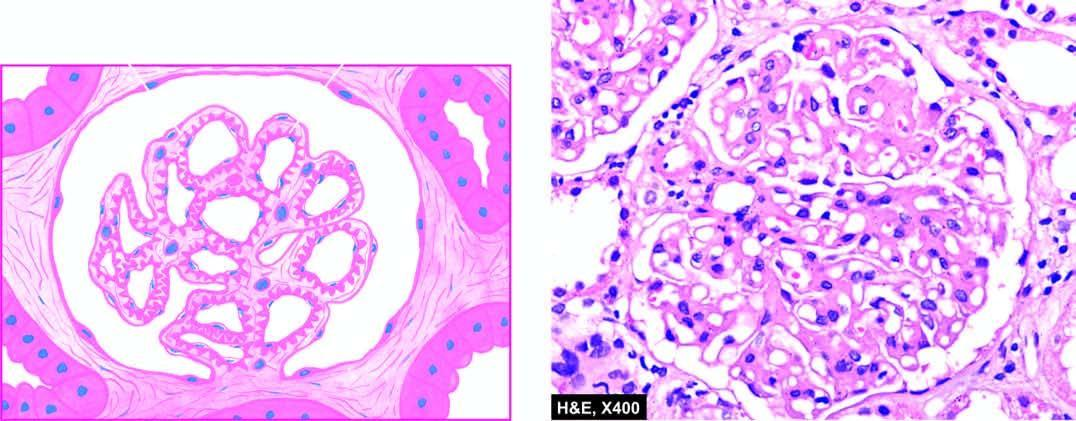re the capillary walls diffusely thickened due to duplication of the gbm?
Answer the question using a single word or phrase. Yes 